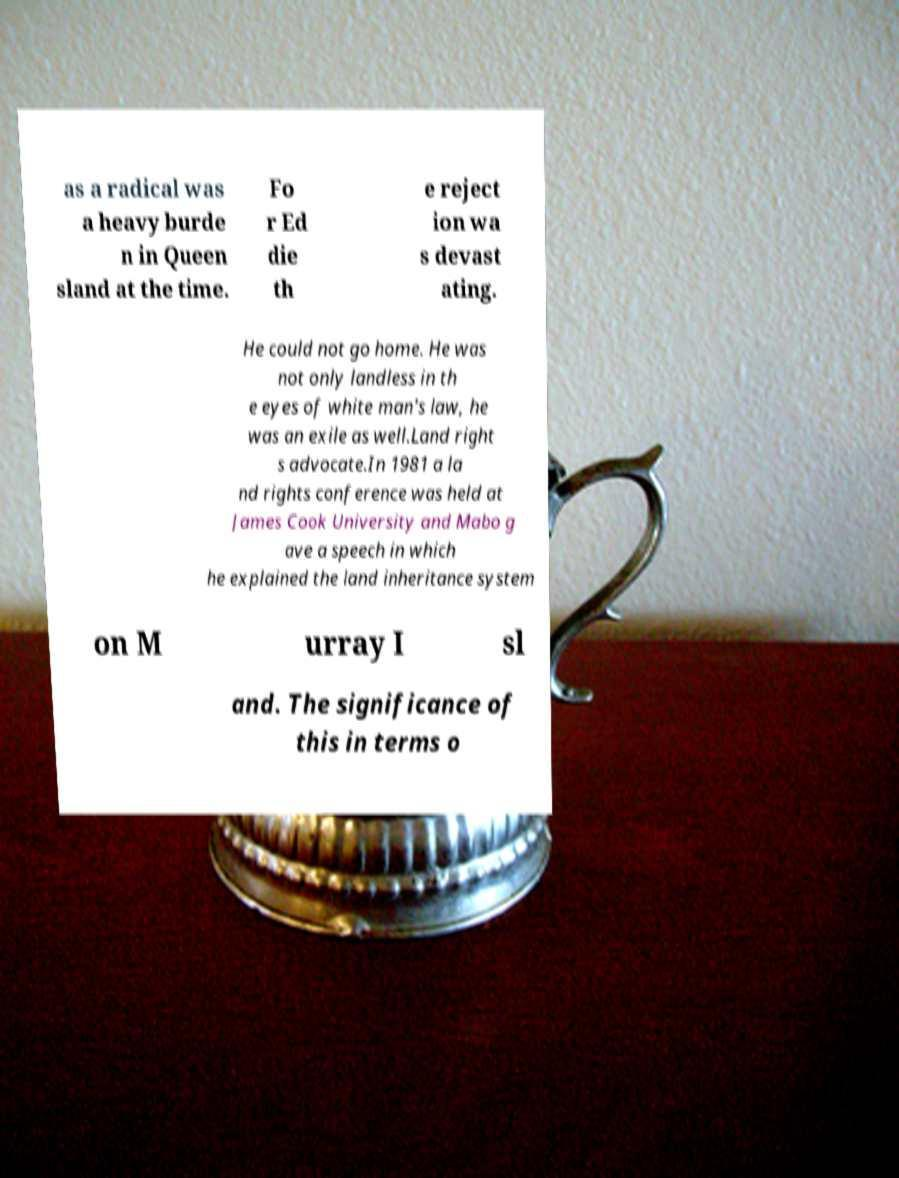Could you assist in decoding the text presented in this image and type it out clearly? as a radical was a heavy burde n in Queen sland at the time. Fo r Ed die th e reject ion wa s devast ating. He could not go home. He was not only landless in th e eyes of white man's law, he was an exile as well.Land right s advocate.In 1981 a la nd rights conference was held at James Cook University and Mabo g ave a speech in which he explained the land inheritance system on M urray I sl and. The significance of this in terms o 